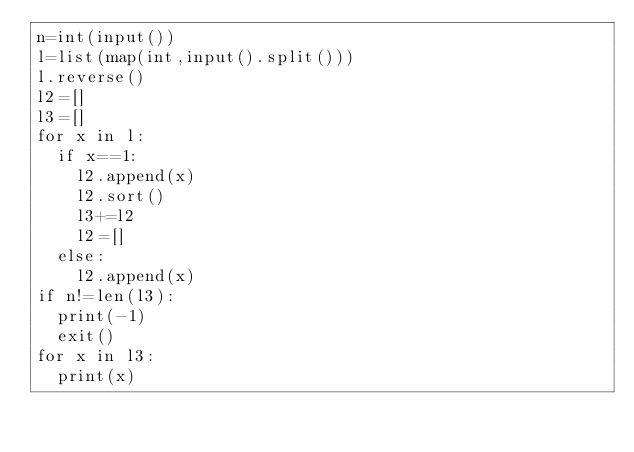Convert code to text. <code><loc_0><loc_0><loc_500><loc_500><_Python_>n=int(input())
l=list(map(int,input().split()))
l.reverse()
l2=[]
l3=[]
for x in l:
  if x==1:
    l2.append(x)
    l2.sort()
    l3+=l2
    l2=[]
  else:
    l2.append(x)
if n!=len(l3):
  print(-1)
  exit()
for x in l3:
  print(x)</code> 